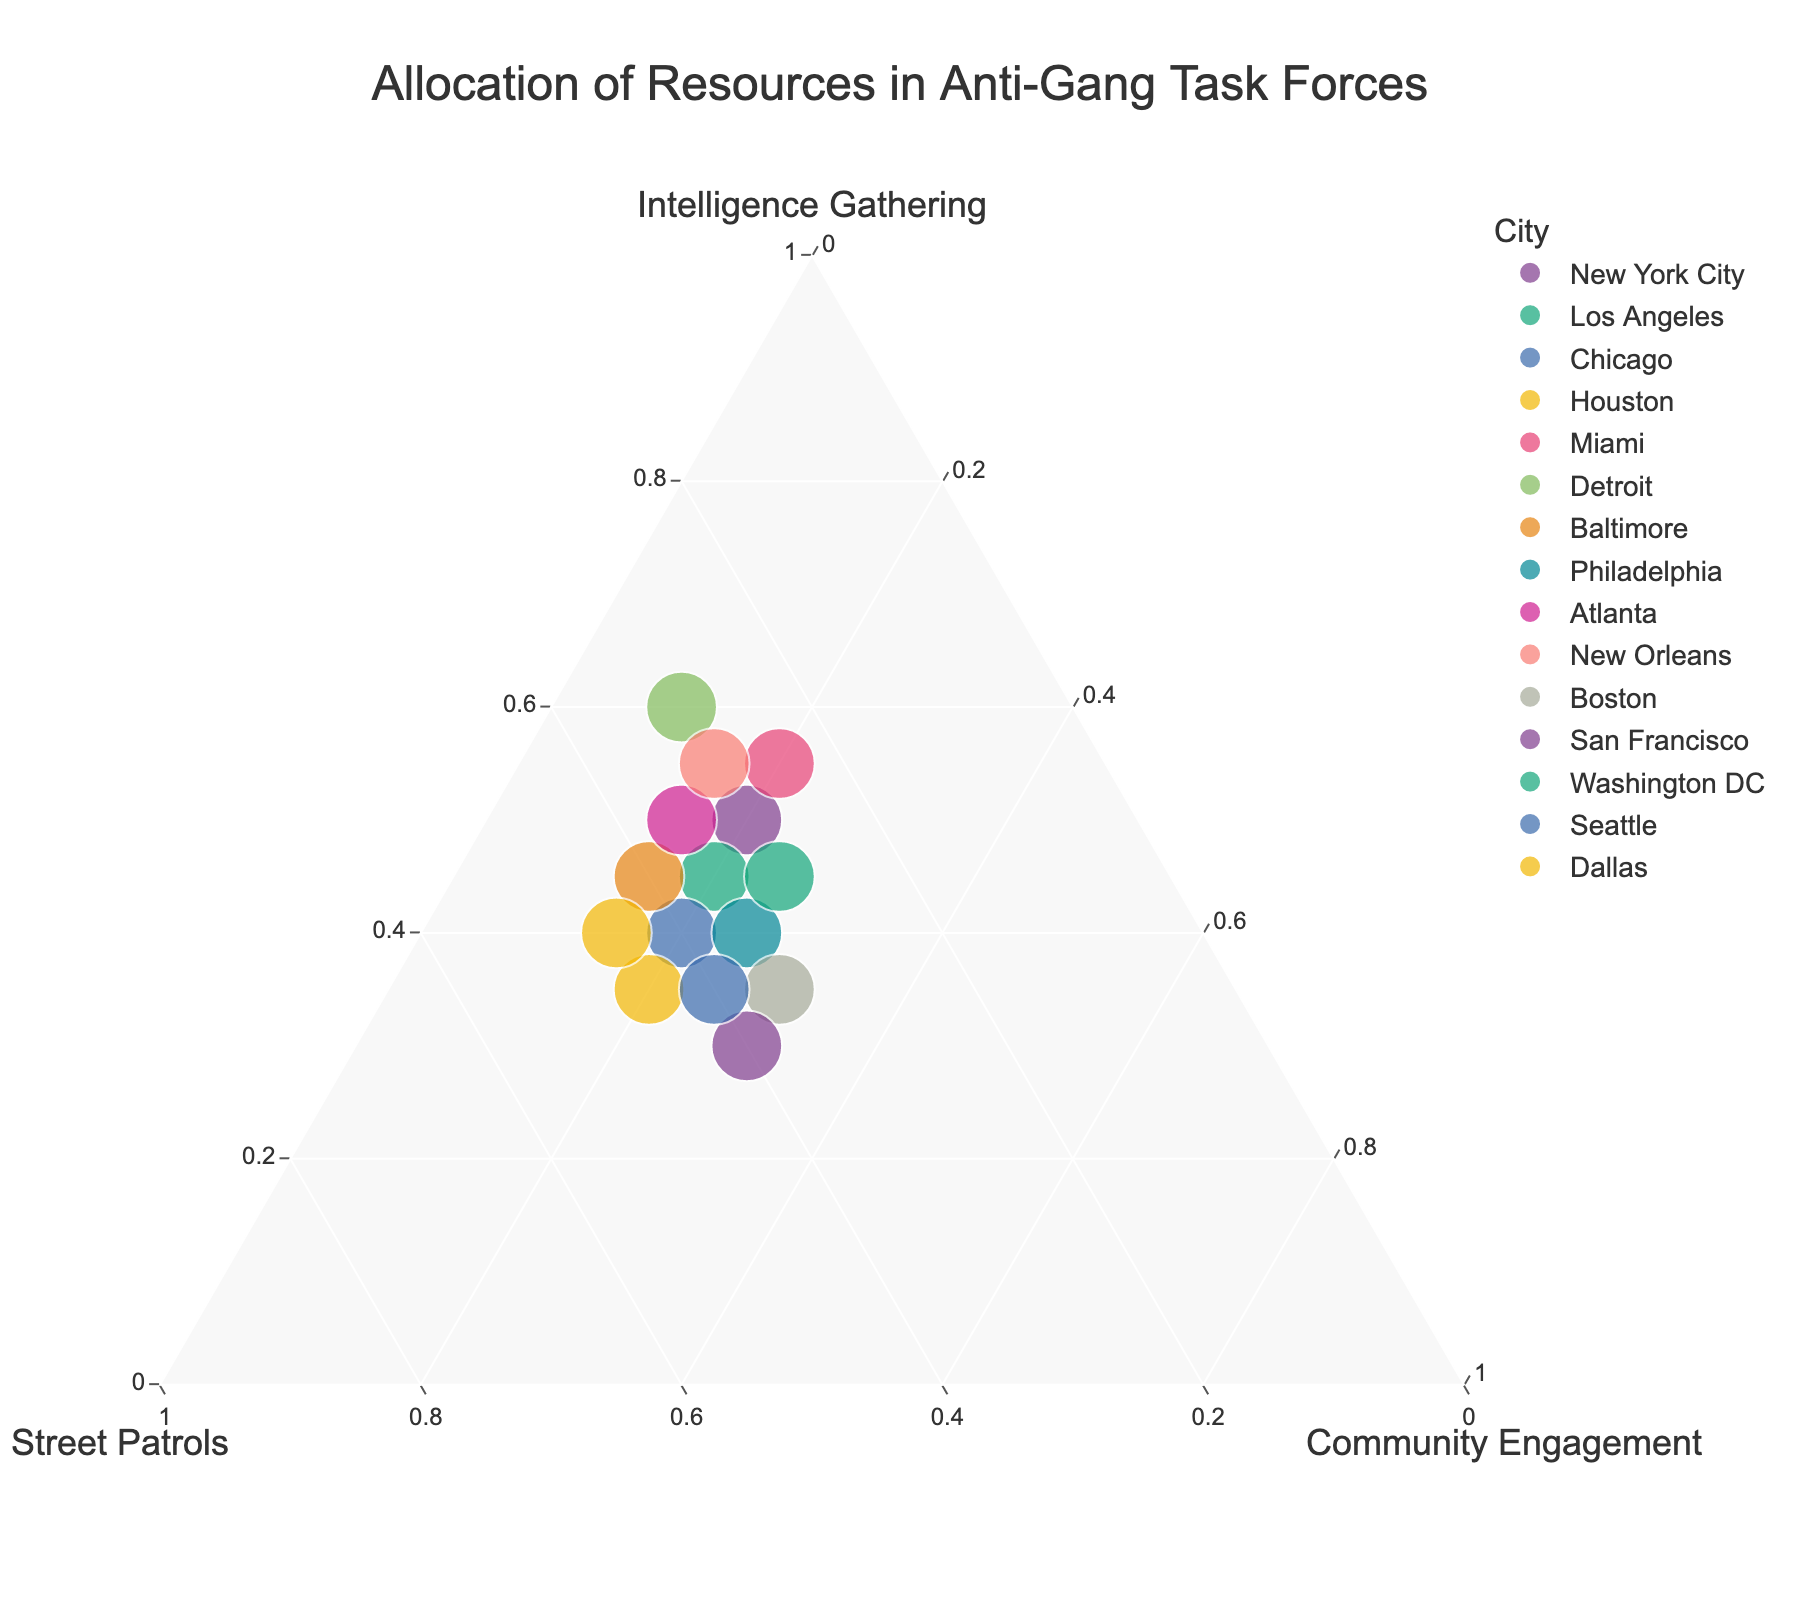What is the title of the plot? The title is usually displayed at the top of the plot, serving as a descriptive label for the visualization. In this plot, it reads "Allocation of Resources in Anti-Gang Task Forces".
Answer: Allocation of Resources in Anti-Gang Task Forces Which city allocates the highest percentage of resources to intelligence gathering? From the ternary plot, point to the data point that is closest to the "Intelligence Gathering" axis. The data point representing Detroit is the closest, indicating the highest percentage (60%).
Answer: Detroit Which cities allocate 25% of their resources to community engagement? Look for the data points located at the 25% mark on the "Community Engagement" axis. Philadelphia, Washington DC, and Seattle all allocate 25% of their resources to community engagement.
Answer: Philadelphia, Washington DC, Seattle How do New York City's and Miami’s resource allocations compare in terms of street patrols? Identify the data points for New York City and Miami and compare their locations relative to the "Street Patrols" axis. New York City allocates 30% to street patrols, while Miami allocates 25%.
Answer: New York City allocates 5% more to street patrols than Miami Which city has the largest allocation to community engagement? Look for the data point closest to the "Community Engagement" corner of the plot. The data point for Boston is closest, indicating the highest allocation of 30% to community engagement.
Answer: Boston What is the combined percentage allocation to street patrols and community engagement for Dallas? Find the data point for Dallas and add together the percentages for street patrols and community engagement. Dallas allocates 45% to street patrols and 15% to community engagement, which sums to 60%.
Answer: 60% Which cities have a balanced allocation between intelligence gathering and street patrols? Look for data points near the middle between the "Intelligence Gathering" and "Street Patrols" axes. Chicago and Baltimore have nearly equal allocations for both categories (~40-45% each).
Answer: Chicago, Baltimore What is the common percentage allocated to community engagement across most cities? Observe the vertical positioning of the data points for the community engagement axis. Most cities consistently allocate 20% to community engagement.
Answer: 20% How do the resource allocations of Los Angeles and Houston differ? Identify the data points for Los Angeles and Houston and compare their positions. Los Angeles: Intelligence Gathering 45%, Street Patrols 35%, Community Engagement 20%. Houston: Intelligence Gathering 35%, Street Patrols 45%, Community Engagement 20%. Los Angeles allocates more to intelligence gathering and less to street patrols compared to Houston.
Answer: Los Angeles allocates more to intelligence gathering, while Houston allocates more to street patrols Which city allocates 10% of its resources to community engagement and how does it allocate the rest? Look for the data point closest to 10% on the "Community Engagement" axis. Detroit matches this criterion, allocating 60% to intelligence gathering and 30% to street patrols.
Answer: Detroit, 60% to intelligence gathering, 30% to street patrols 